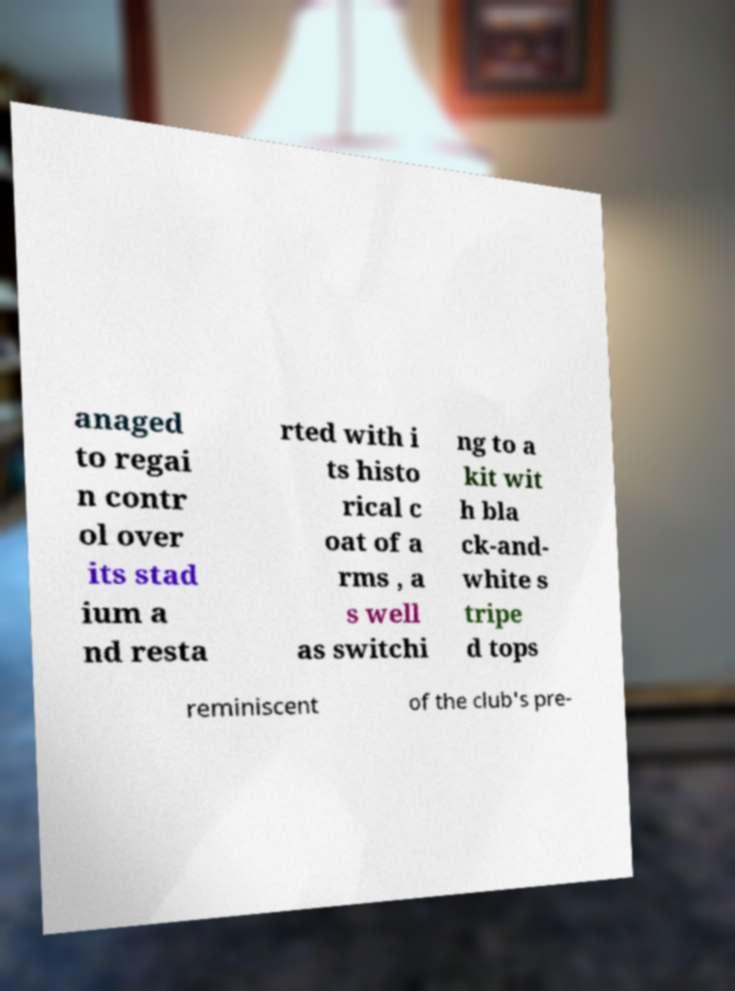Can you read and provide the text displayed in the image?This photo seems to have some interesting text. Can you extract and type it out for me? anaged to regai n contr ol over its stad ium a nd resta rted with i ts histo rical c oat of a rms , a s well as switchi ng to a kit wit h bla ck-and- white s tripe d tops reminiscent of the club's pre- 